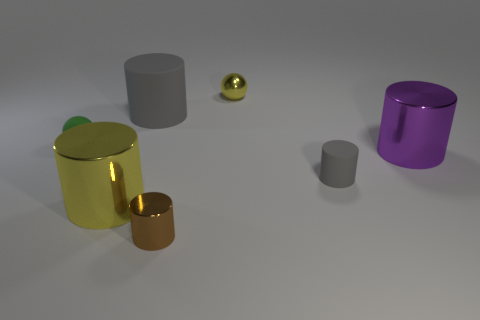What materials do these objects appear to be made of? The objects in the image appear to be made of various metals, as indicated by their shiny, reflective surfaces. The finishes suggest that some are perhaps more polished, like the sphere, while others have a more matte look, as seen on the two cylinders. 